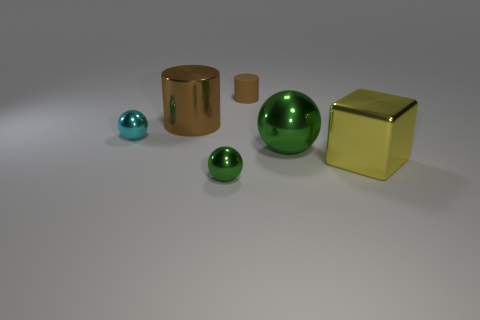Is there anything else that has the same shape as the large yellow thing?
Your answer should be very brief. No. Does the tiny rubber object have the same color as the large metallic cylinder?
Provide a succinct answer. Yes. Are there more large brown metal objects that are to the left of the large brown cylinder than tiny shiny spheres behind the large yellow metallic object?
Your response must be concise. No. There is a metal thing behind the small cyan object; is it the same size as the metal thing on the right side of the big green metal object?
Your answer should be compact. Yes. There is a brown shiny object; what shape is it?
Your response must be concise. Cylinder. There is a matte cylinder that is the same color as the shiny cylinder; what is its size?
Make the answer very short. Small. What is the color of the large cylinder that is the same material as the tiny green thing?
Make the answer very short. Brown. Is the small cylinder made of the same material as the green object behind the yellow shiny cube?
Your answer should be very brief. No. The tiny rubber object has what color?
Offer a terse response. Brown. The cyan ball that is made of the same material as the yellow block is what size?
Your response must be concise. Small. 